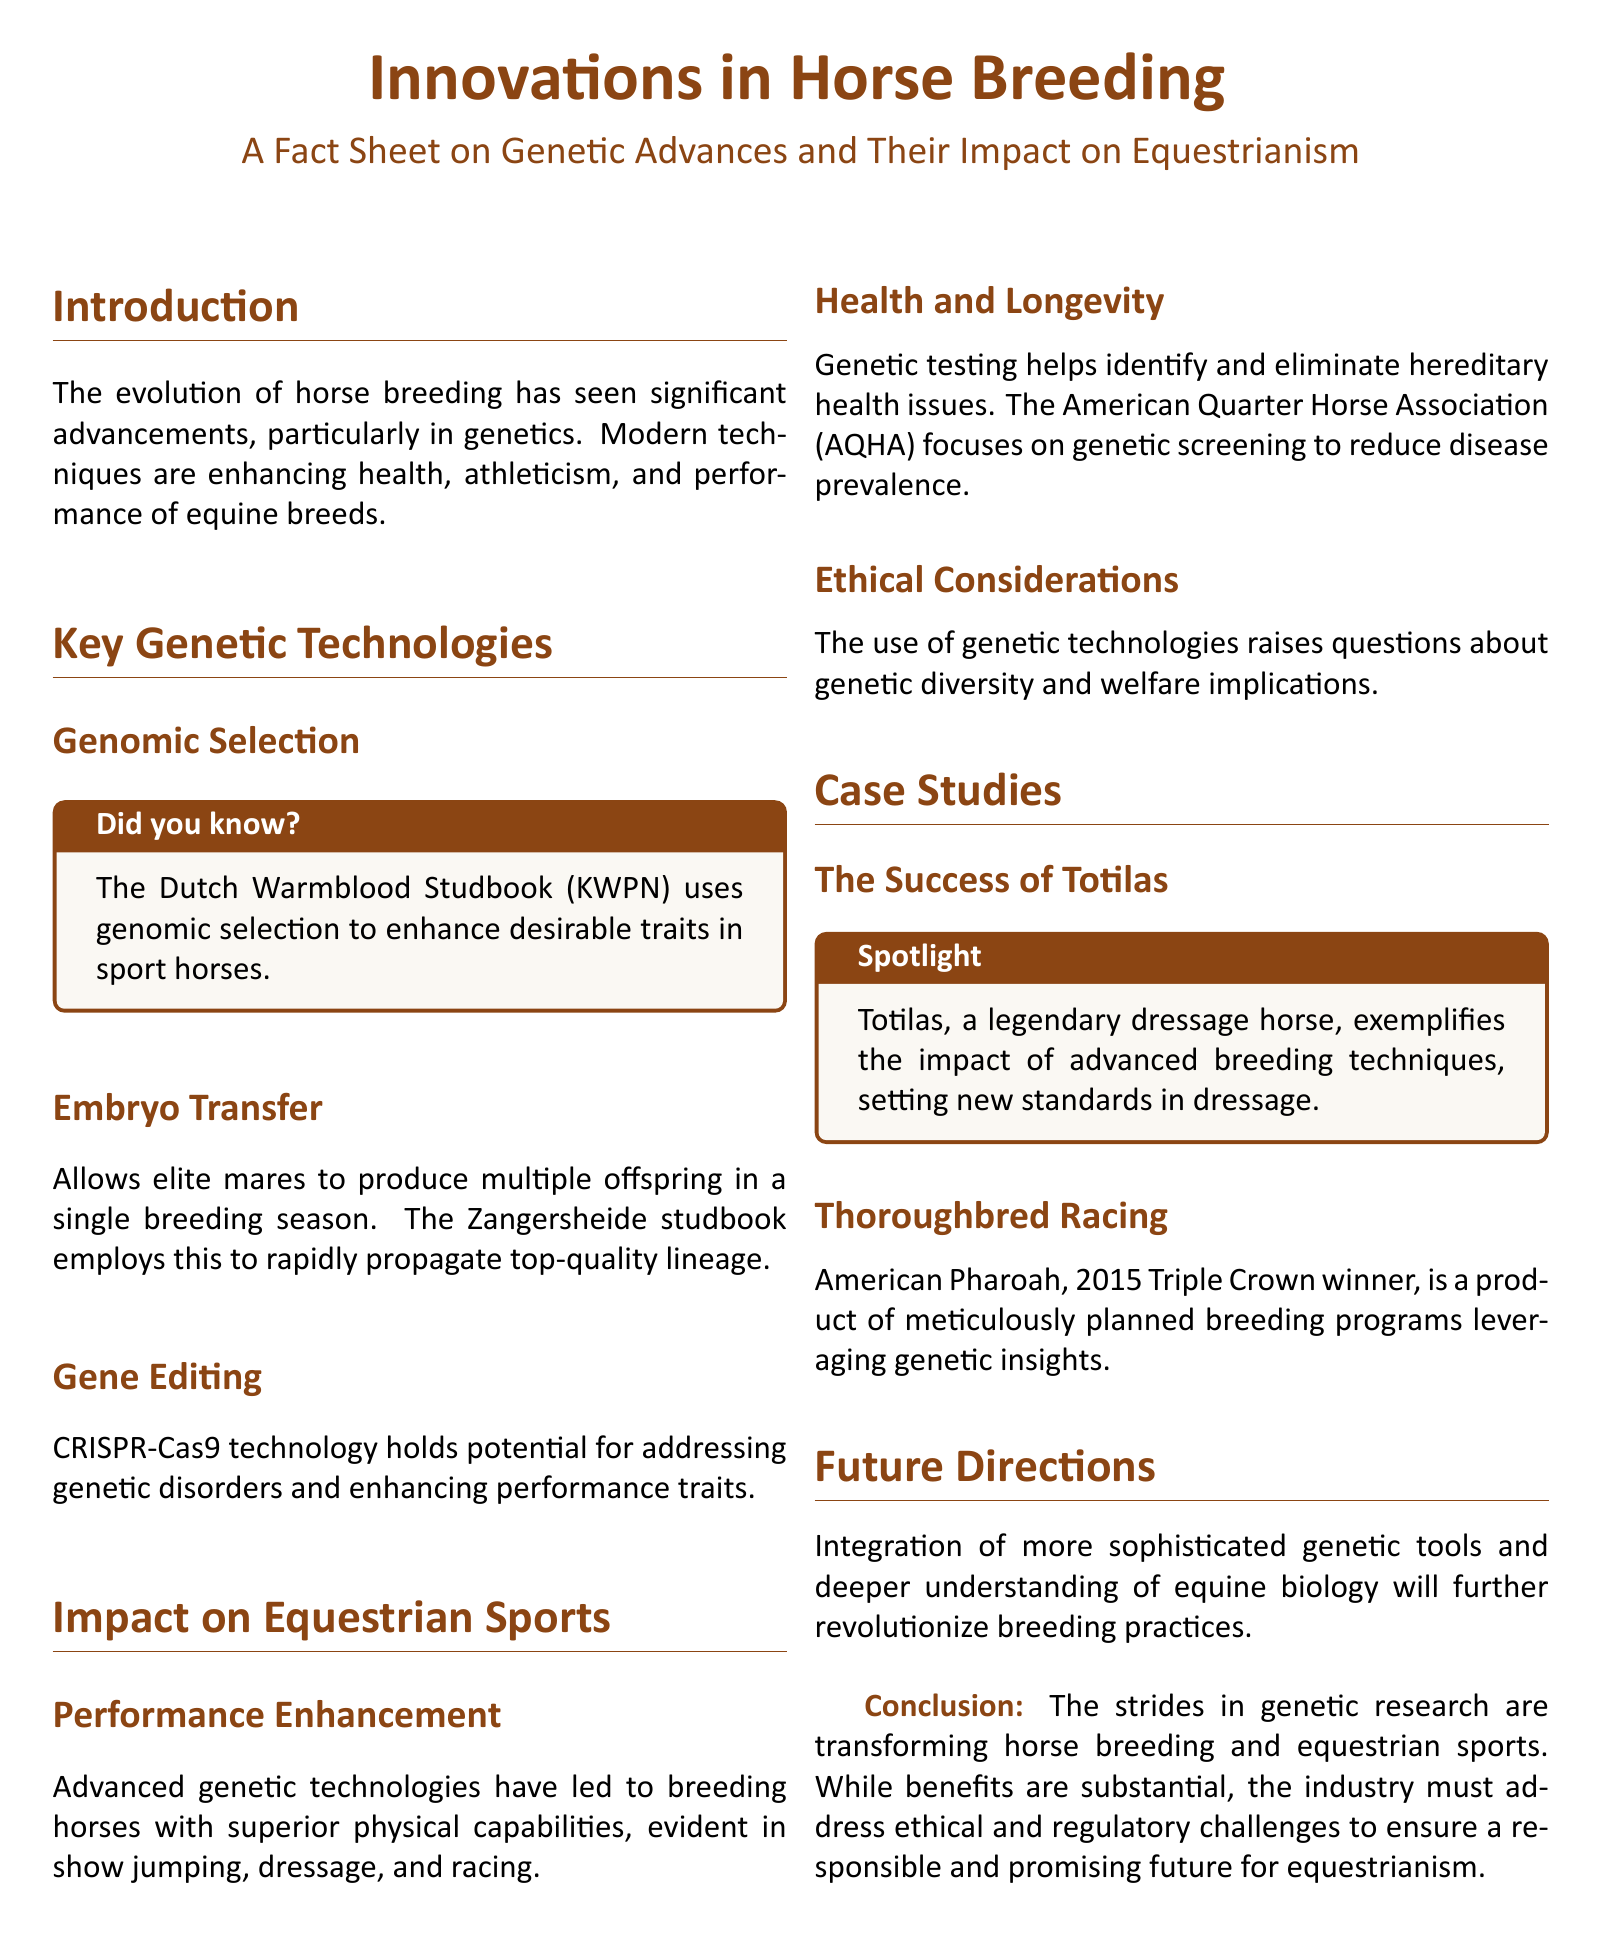what is the title of the document? The title is presented at the top of the document, stating the main subject it covers.
Answer: Innovations in Horse Breeding what technology does the Dutch Warmblood Studbook use? The document specifies that this studbook employs a particular genetic approach to improve horse traits.
Answer: Genomic selection what breeding method allows elite mares to produce multiple offspring? The document explains a modern technique used in breeding that facilitates increased production from top mares.
Answer: Embryo transfer who is a notable dressage horse mentioned in the document? A specific horse that serves as a case study highlighting the results of advanced breeding methods is named in the text.
Answer: Totilas what is the primary focus of the American Quarter Horse Association regarding genetics? The document states a specific aim of this association concerning health issues in horses.
Answer: Genetic screening what genetic technology is mentioned as holding potential for genetic disorders? The document identifies a cutting-edge scientific method that provides solutions for genetic issues in horses.
Answer: CRISPR-Cas9 which equestrian sport benefits from advanced genetic technologies for breeding horses? The document outlines specific sports where improved horse capabilities due to genetics are clearly observed.
Answer: Show jumping what is a significant outcome of the advancements in horse breeding mentioned in the document? The text concludes with the key benefits that arise from the improvements in genetic research within equestrianism.
Answer: Transformation of equestrian sports what ethical aspect is raised concerning genetic technologies in horse breeding? The document points out a concern related to the implications of these technologies on horse breeding practices.
Answer: Genetic diversity 